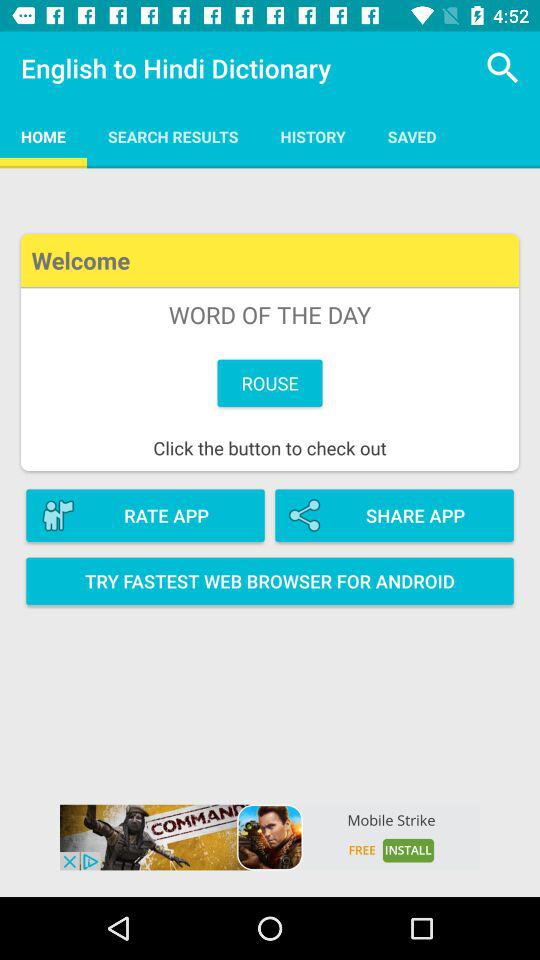What is the application name? The application name is "English to Hindi Dictionary". 